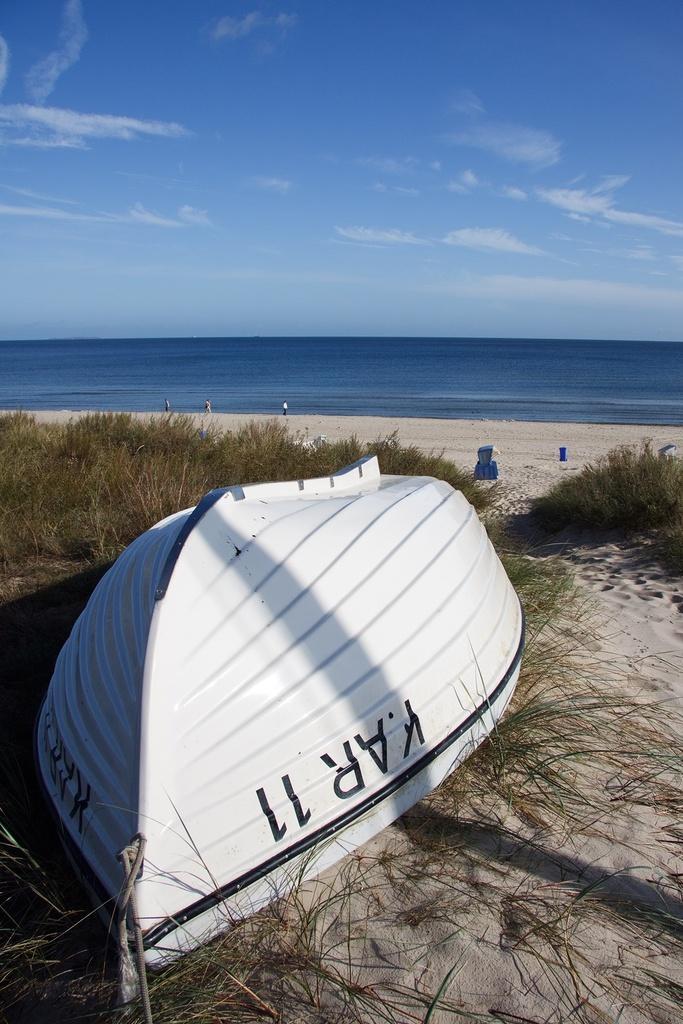How would you summarize this image in a sentence or two? In this picture we can observe white color boat in the beach. There are some plants on the ground. In the background there is an ocean and a sky with some clouds. 